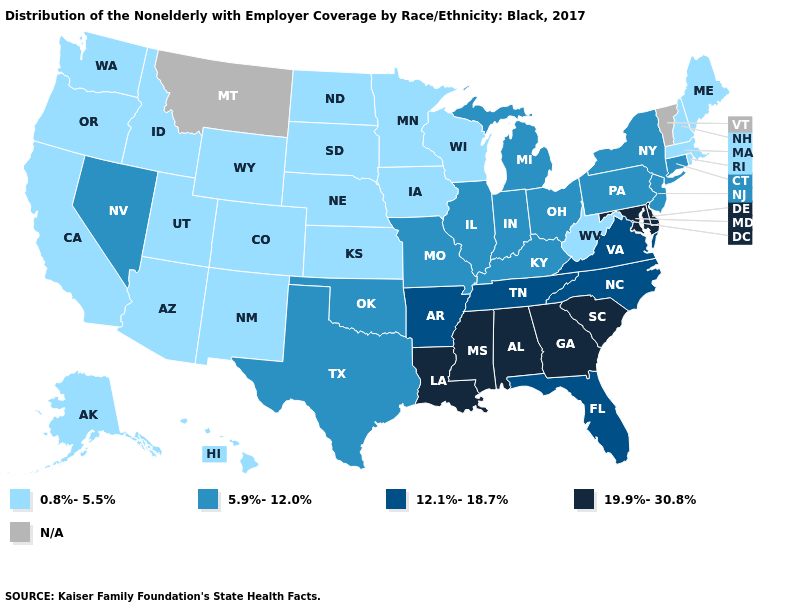Among the states that border Montana , which have the highest value?
Short answer required. Idaho, North Dakota, South Dakota, Wyoming. Which states have the lowest value in the MidWest?
Concise answer only. Iowa, Kansas, Minnesota, Nebraska, North Dakota, South Dakota, Wisconsin. Name the states that have a value in the range 12.1%-18.7%?
Quick response, please. Arkansas, Florida, North Carolina, Tennessee, Virginia. Does the first symbol in the legend represent the smallest category?
Be succinct. Yes. Does Alaska have the highest value in the USA?
Be succinct. No. Is the legend a continuous bar?
Write a very short answer. No. Does the first symbol in the legend represent the smallest category?
Concise answer only. Yes. Name the states that have a value in the range 0.8%-5.5%?
Give a very brief answer. Alaska, Arizona, California, Colorado, Hawaii, Idaho, Iowa, Kansas, Maine, Massachusetts, Minnesota, Nebraska, New Hampshire, New Mexico, North Dakota, Oregon, Rhode Island, South Dakota, Utah, Washington, West Virginia, Wisconsin, Wyoming. Among the states that border Ohio , which have the highest value?
Short answer required. Indiana, Kentucky, Michigan, Pennsylvania. What is the lowest value in the Northeast?
Write a very short answer. 0.8%-5.5%. Does Pennsylvania have the highest value in the Northeast?
Write a very short answer. Yes. Does the map have missing data?
Quick response, please. Yes. Name the states that have a value in the range 5.9%-12.0%?
Short answer required. Connecticut, Illinois, Indiana, Kentucky, Michigan, Missouri, Nevada, New Jersey, New York, Ohio, Oklahoma, Pennsylvania, Texas. What is the value of Oregon?
Give a very brief answer. 0.8%-5.5%. 